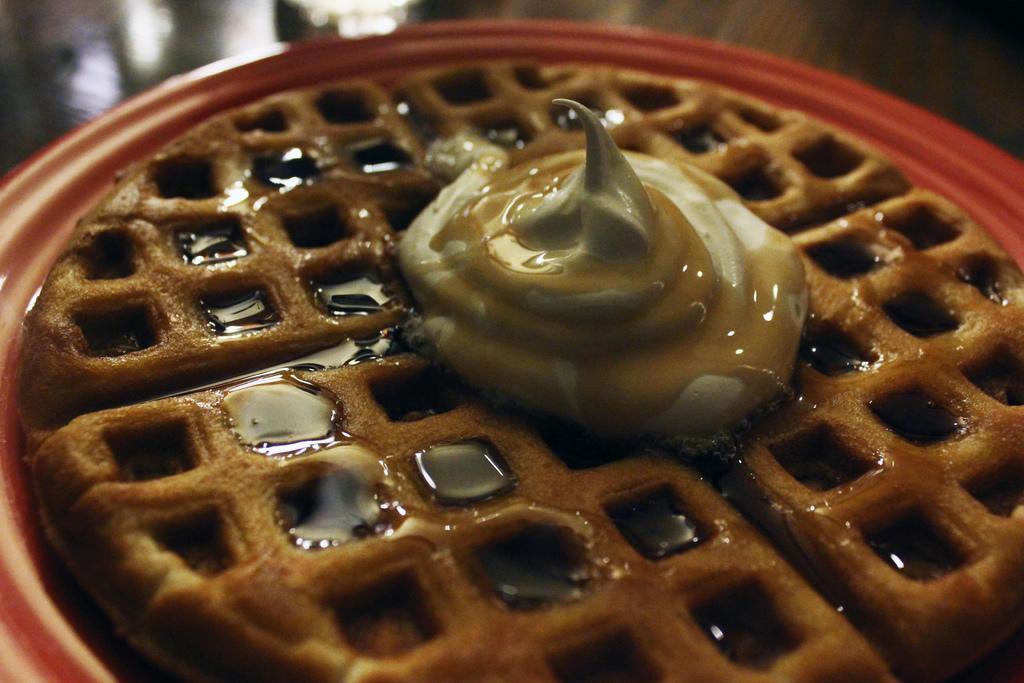Describe this image in one or two sentences. In this picture we can see food in the plate. 